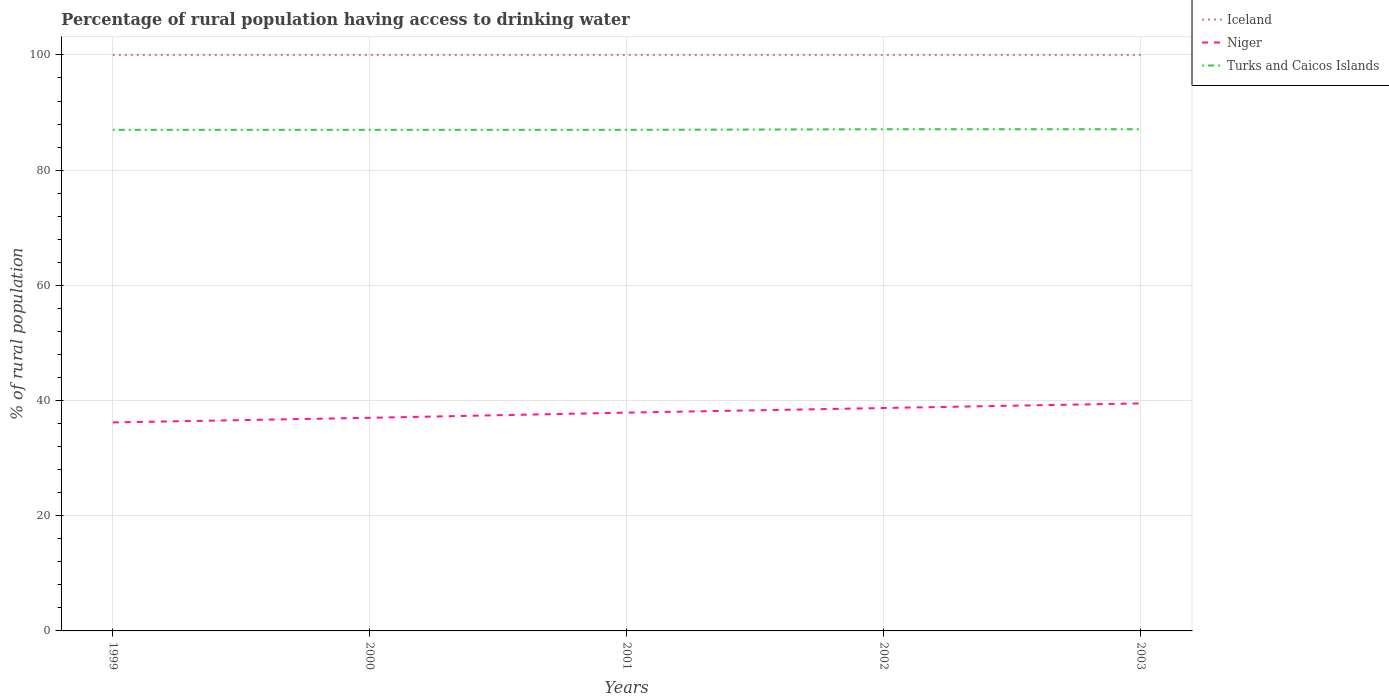Does the line corresponding to Niger intersect with the line corresponding to Iceland?
Make the answer very short. No. Is the number of lines equal to the number of legend labels?
Give a very brief answer. Yes. Across all years, what is the maximum percentage of rural population having access to drinking water in Niger?
Offer a very short reply. 36.2. What is the difference between the highest and the second highest percentage of rural population having access to drinking water in Turks and Caicos Islands?
Keep it short and to the point. 0.1. What is the difference between the highest and the lowest percentage of rural population having access to drinking water in Iceland?
Your answer should be compact. 0. Is the percentage of rural population having access to drinking water in Iceland strictly greater than the percentage of rural population having access to drinking water in Niger over the years?
Your answer should be compact. No. How many lines are there?
Give a very brief answer. 3. Are the values on the major ticks of Y-axis written in scientific E-notation?
Your response must be concise. No. Does the graph contain any zero values?
Ensure brevity in your answer.  No. Does the graph contain grids?
Provide a succinct answer. Yes. Where does the legend appear in the graph?
Provide a short and direct response. Top right. How many legend labels are there?
Give a very brief answer. 3. What is the title of the graph?
Provide a short and direct response. Percentage of rural population having access to drinking water. Does "Middle income" appear as one of the legend labels in the graph?
Keep it short and to the point. No. What is the label or title of the Y-axis?
Offer a very short reply. % of rural population. What is the % of rural population of Iceland in 1999?
Provide a succinct answer. 100. What is the % of rural population in Niger in 1999?
Ensure brevity in your answer.  36.2. What is the % of rural population in Turks and Caicos Islands in 1999?
Make the answer very short. 87. What is the % of rural population of Iceland in 2000?
Provide a succinct answer. 100. What is the % of rural population of Iceland in 2001?
Offer a terse response. 100. What is the % of rural population in Niger in 2001?
Give a very brief answer. 37.9. What is the % of rural population in Iceland in 2002?
Provide a short and direct response. 100. What is the % of rural population in Niger in 2002?
Ensure brevity in your answer.  38.7. What is the % of rural population of Turks and Caicos Islands in 2002?
Ensure brevity in your answer.  87.1. What is the % of rural population in Iceland in 2003?
Your answer should be very brief. 100. What is the % of rural population in Niger in 2003?
Provide a succinct answer. 39.5. What is the % of rural population in Turks and Caicos Islands in 2003?
Your answer should be compact. 87.1. Across all years, what is the maximum % of rural population of Niger?
Give a very brief answer. 39.5. Across all years, what is the maximum % of rural population of Turks and Caicos Islands?
Give a very brief answer. 87.1. Across all years, what is the minimum % of rural population in Niger?
Give a very brief answer. 36.2. Across all years, what is the minimum % of rural population of Turks and Caicos Islands?
Offer a very short reply. 87. What is the total % of rural population of Niger in the graph?
Your response must be concise. 189.3. What is the total % of rural population of Turks and Caicos Islands in the graph?
Ensure brevity in your answer.  435.2. What is the difference between the % of rural population in Turks and Caicos Islands in 1999 and that in 2000?
Make the answer very short. 0. What is the difference between the % of rural population of Iceland in 1999 and that in 2001?
Offer a very short reply. 0. What is the difference between the % of rural population of Niger in 1999 and that in 2001?
Offer a very short reply. -1.7. What is the difference between the % of rural population in Iceland in 1999 and that in 2002?
Provide a succinct answer. 0. What is the difference between the % of rural population of Niger in 1999 and that in 2003?
Your answer should be compact. -3.3. What is the difference between the % of rural population of Turks and Caicos Islands in 1999 and that in 2003?
Give a very brief answer. -0.1. What is the difference between the % of rural population of Niger in 2000 and that in 2001?
Ensure brevity in your answer.  -0.9. What is the difference between the % of rural population of Iceland in 2000 and that in 2002?
Give a very brief answer. 0. What is the difference between the % of rural population in Turks and Caicos Islands in 2000 and that in 2002?
Give a very brief answer. -0.1. What is the difference between the % of rural population in Turks and Caicos Islands in 2000 and that in 2003?
Make the answer very short. -0.1. What is the difference between the % of rural population of Iceland in 2001 and that in 2003?
Give a very brief answer. 0. What is the difference between the % of rural population in Iceland in 2002 and that in 2003?
Give a very brief answer. 0. What is the difference between the % of rural population in Niger in 2002 and that in 2003?
Your answer should be compact. -0.8. What is the difference between the % of rural population in Niger in 1999 and the % of rural population in Turks and Caicos Islands in 2000?
Your response must be concise. -50.8. What is the difference between the % of rural population of Iceland in 1999 and the % of rural population of Niger in 2001?
Your answer should be very brief. 62.1. What is the difference between the % of rural population of Niger in 1999 and the % of rural population of Turks and Caicos Islands in 2001?
Give a very brief answer. -50.8. What is the difference between the % of rural population of Iceland in 1999 and the % of rural population of Niger in 2002?
Provide a short and direct response. 61.3. What is the difference between the % of rural population of Iceland in 1999 and the % of rural population of Turks and Caicos Islands in 2002?
Give a very brief answer. 12.9. What is the difference between the % of rural population in Niger in 1999 and the % of rural population in Turks and Caicos Islands in 2002?
Your answer should be very brief. -50.9. What is the difference between the % of rural population of Iceland in 1999 and the % of rural population of Niger in 2003?
Keep it short and to the point. 60.5. What is the difference between the % of rural population in Iceland in 1999 and the % of rural population in Turks and Caicos Islands in 2003?
Keep it short and to the point. 12.9. What is the difference between the % of rural population in Niger in 1999 and the % of rural population in Turks and Caicos Islands in 2003?
Ensure brevity in your answer.  -50.9. What is the difference between the % of rural population of Iceland in 2000 and the % of rural population of Niger in 2001?
Your answer should be very brief. 62.1. What is the difference between the % of rural population in Iceland in 2000 and the % of rural population in Turks and Caicos Islands in 2001?
Ensure brevity in your answer.  13. What is the difference between the % of rural population in Niger in 2000 and the % of rural population in Turks and Caicos Islands in 2001?
Offer a terse response. -50. What is the difference between the % of rural population in Iceland in 2000 and the % of rural population in Niger in 2002?
Give a very brief answer. 61.3. What is the difference between the % of rural population of Niger in 2000 and the % of rural population of Turks and Caicos Islands in 2002?
Provide a succinct answer. -50.1. What is the difference between the % of rural population in Iceland in 2000 and the % of rural population in Niger in 2003?
Provide a succinct answer. 60.5. What is the difference between the % of rural population of Niger in 2000 and the % of rural population of Turks and Caicos Islands in 2003?
Give a very brief answer. -50.1. What is the difference between the % of rural population of Iceland in 2001 and the % of rural population of Niger in 2002?
Provide a succinct answer. 61.3. What is the difference between the % of rural population in Iceland in 2001 and the % of rural population in Turks and Caicos Islands in 2002?
Provide a short and direct response. 12.9. What is the difference between the % of rural population of Niger in 2001 and the % of rural population of Turks and Caicos Islands in 2002?
Your answer should be very brief. -49.2. What is the difference between the % of rural population of Iceland in 2001 and the % of rural population of Niger in 2003?
Your answer should be very brief. 60.5. What is the difference between the % of rural population in Niger in 2001 and the % of rural population in Turks and Caicos Islands in 2003?
Keep it short and to the point. -49.2. What is the difference between the % of rural population of Iceland in 2002 and the % of rural population of Niger in 2003?
Provide a short and direct response. 60.5. What is the difference between the % of rural population in Iceland in 2002 and the % of rural population in Turks and Caicos Islands in 2003?
Your answer should be compact. 12.9. What is the difference between the % of rural population of Niger in 2002 and the % of rural population of Turks and Caicos Islands in 2003?
Give a very brief answer. -48.4. What is the average % of rural population of Niger per year?
Offer a very short reply. 37.86. What is the average % of rural population of Turks and Caicos Islands per year?
Your response must be concise. 87.04. In the year 1999, what is the difference between the % of rural population in Iceland and % of rural population in Niger?
Ensure brevity in your answer.  63.8. In the year 1999, what is the difference between the % of rural population in Iceland and % of rural population in Turks and Caicos Islands?
Offer a very short reply. 13. In the year 1999, what is the difference between the % of rural population of Niger and % of rural population of Turks and Caicos Islands?
Make the answer very short. -50.8. In the year 2000, what is the difference between the % of rural population in Iceland and % of rural population in Turks and Caicos Islands?
Your response must be concise. 13. In the year 2001, what is the difference between the % of rural population of Iceland and % of rural population of Niger?
Your answer should be compact. 62.1. In the year 2001, what is the difference between the % of rural population in Niger and % of rural population in Turks and Caicos Islands?
Keep it short and to the point. -49.1. In the year 2002, what is the difference between the % of rural population of Iceland and % of rural population of Niger?
Offer a terse response. 61.3. In the year 2002, what is the difference between the % of rural population in Iceland and % of rural population in Turks and Caicos Islands?
Your response must be concise. 12.9. In the year 2002, what is the difference between the % of rural population of Niger and % of rural population of Turks and Caicos Islands?
Your answer should be very brief. -48.4. In the year 2003, what is the difference between the % of rural population in Iceland and % of rural population in Niger?
Offer a terse response. 60.5. In the year 2003, what is the difference between the % of rural population of Niger and % of rural population of Turks and Caicos Islands?
Offer a very short reply. -47.6. What is the ratio of the % of rural population of Iceland in 1999 to that in 2000?
Your response must be concise. 1. What is the ratio of the % of rural population in Niger in 1999 to that in 2000?
Provide a short and direct response. 0.98. What is the ratio of the % of rural population of Niger in 1999 to that in 2001?
Keep it short and to the point. 0.96. What is the ratio of the % of rural population in Iceland in 1999 to that in 2002?
Give a very brief answer. 1. What is the ratio of the % of rural population of Niger in 1999 to that in 2002?
Offer a terse response. 0.94. What is the ratio of the % of rural population of Turks and Caicos Islands in 1999 to that in 2002?
Provide a succinct answer. 1. What is the ratio of the % of rural population in Iceland in 1999 to that in 2003?
Keep it short and to the point. 1. What is the ratio of the % of rural population in Niger in 1999 to that in 2003?
Your answer should be compact. 0.92. What is the ratio of the % of rural population in Turks and Caicos Islands in 1999 to that in 2003?
Make the answer very short. 1. What is the ratio of the % of rural population in Iceland in 2000 to that in 2001?
Your response must be concise. 1. What is the ratio of the % of rural population in Niger in 2000 to that in 2001?
Ensure brevity in your answer.  0.98. What is the ratio of the % of rural population of Iceland in 2000 to that in 2002?
Give a very brief answer. 1. What is the ratio of the % of rural population in Niger in 2000 to that in 2002?
Your response must be concise. 0.96. What is the ratio of the % of rural population in Iceland in 2000 to that in 2003?
Make the answer very short. 1. What is the ratio of the % of rural population in Niger in 2000 to that in 2003?
Your response must be concise. 0.94. What is the ratio of the % of rural population of Iceland in 2001 to that in 2002?
Keep it short and to the point. 1. What is the ratio of the % of rural population in Niger in 2001 to that in 2002?
Your response must be concise. 0.98. What is the ratio of the % of rural population in Turks and Caicos Islands in 2001 to that in 2002?
Keep it short and to the point. 1. What is the ratio of the % of rural population in Niger in 2001 to that in 2003?
Your response must be concise. 0.96. What is the ratio of the % of rural population of Turks and Caicos Islands in 2001 to that in 2003?
Offer a terse response. 1. What is the ratio of the % of rural population in Niger in 2002 to that in 2003?
Offer a terse response. 0.98. What is the difference between the highest and the second highest % of rural population of Turks and Caicos Islands?
Provide a succinct answer. 0. What is the difference between the highest and the lowest % of rural population of Iceland?
Make the answer very short. 0. What is the difference between the highest and the lowest % of rural population of Turks and Caicos Islands?
Offer a very short reply. 0.1. 